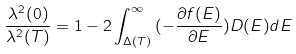Convert formula to latex. <formula><loc_0><loc_0><loc_500><loc_500>\frac { \lambda ^ { 2 } ( 0 ) } { \lambda ^ { 2 } ( T ) } = 1 - 2 \int ^ { \infty } _ { \Delta ( T ) } { ( - \frac { \partial { f ( E ) } } { \partial { E } } ) D ( E ) } d E</formula> 